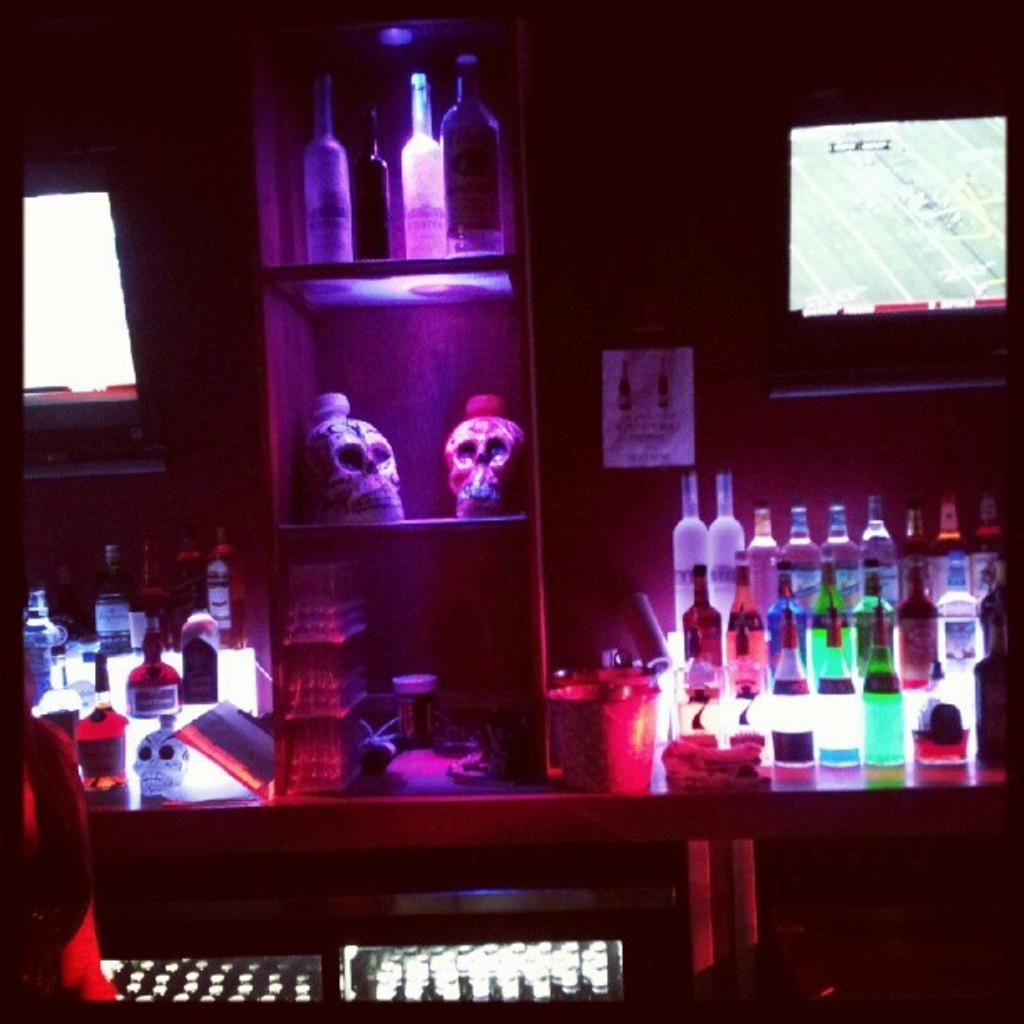Please provide a concise description of this image. This picture is consists of a bar picture where there are bottles of drinks and a small bucket on the desk. 